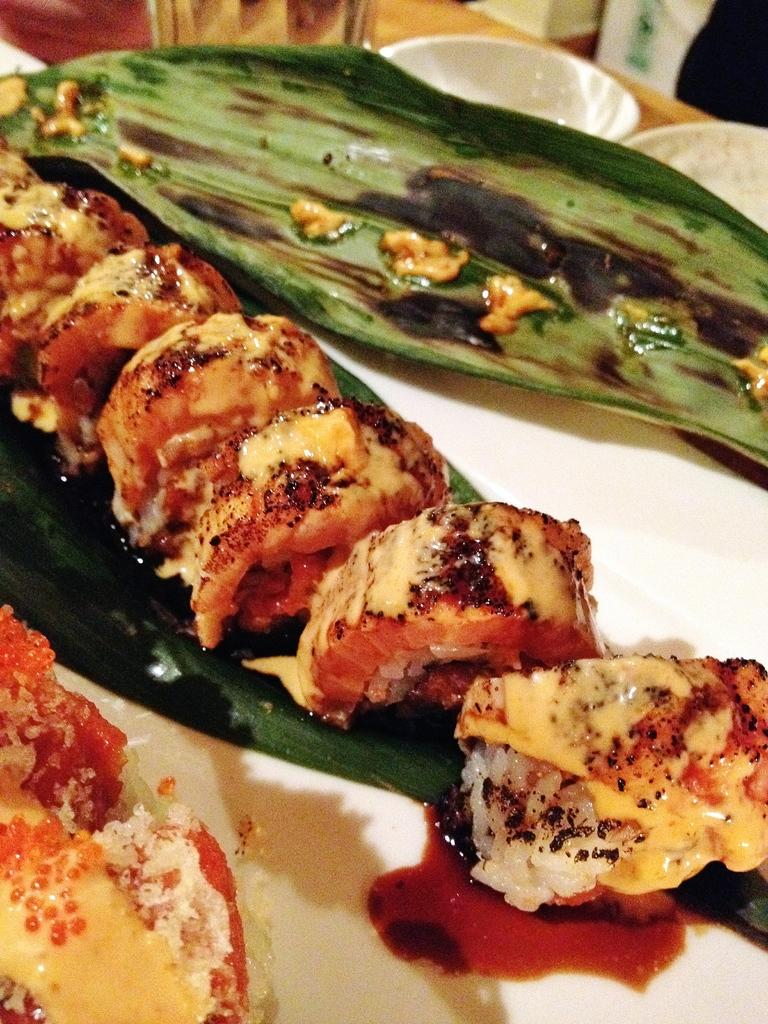What is on the plate that is visible in the image? There are food items on a plate in the image. What is beside the plate? There is a glass beside the plate. What type of containers are present in the image? There are bowls in the image. Where are the plate, glass, and bowls located? The plate, glass, and bowls are placed on a platform. What can be seen in the background of the image? There are objects visible in the background of the image. What type of pot is visible on the roof in the image? There is no pot visible on a roof in the image; the image only shows a plate, glass, bowls, and objects in the background. 